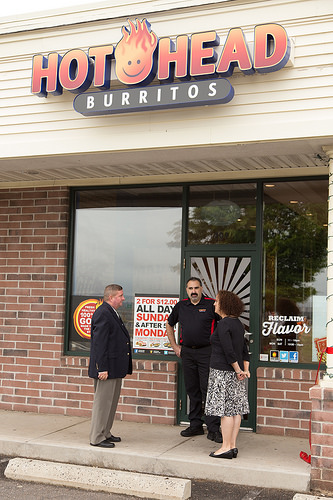<image>
Can you confirm if the women is to the left of the men? No. The women is not to the left of the men. From this viewpoint, they have a different horizontal relationship. Is the window behind the woman? No. The window is not behind the woman. From this viewpoint, the window appears to be positioned elsewhere in the scene. 